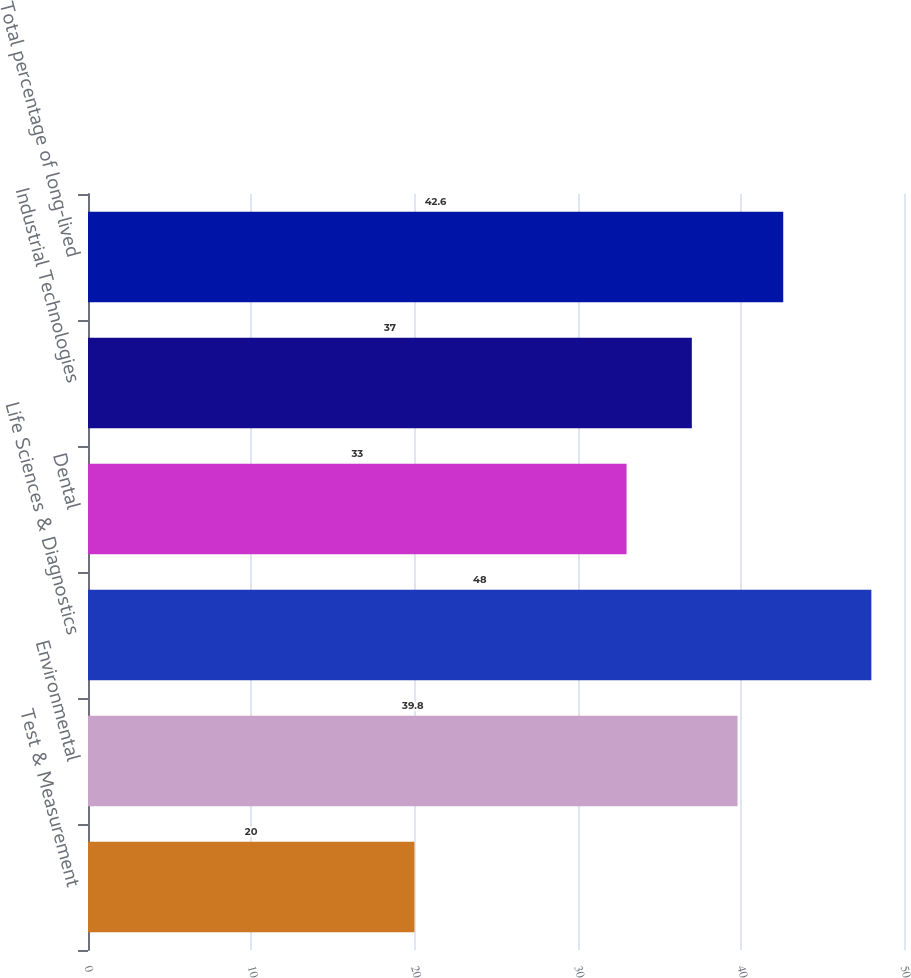Convert chart. <chart><loc_0><loc_0><loc_500><loc_500><bar_chart><fcel>Test & Measurement<fcel>Environmental<fcel>Life Sciences & Diagnostics<fcel>Dental<fcel>Industrial Technologies<fcel>Total percentage of long-lived<nl><fcel>20<fcel>39.8<fcel>48<fcel>33<fcel>37<fcel>42.6<nl></chart> 